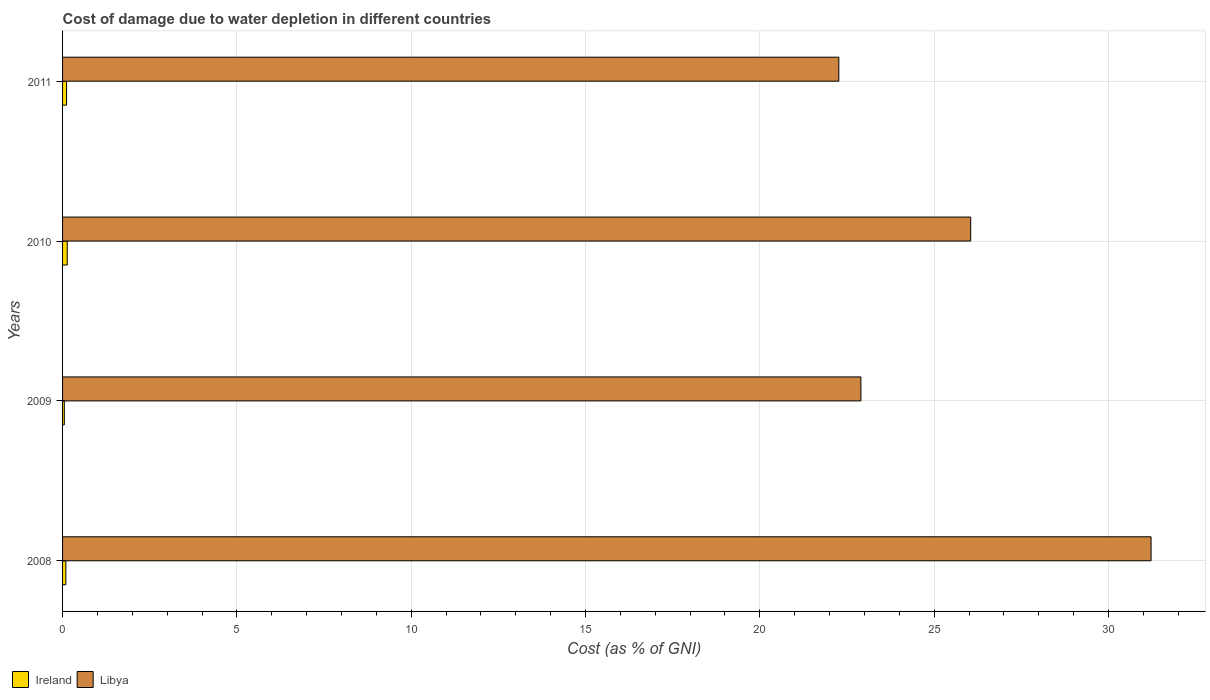How many different coloured bars are there?
Your response must be concise. 2. Are the number of bars per tick equal to the number of legend labels?
Your answer should be very brief. Yes. How many bars are there on the 3rd tick from the top?
Make the answer very short. 2. What is the label of the 3rd group of bars from the top?
Provide a short and direct response. 2009. What is the cost of damage caused due to water depletion in Libya in 2011?
Offer a very short reply. 22.26. Across all years, what is the maximum cost of damage caused due to water depletion in Ireland?
Your answer should be very brief. 0.13. Across all years, what is the minimum cost of damage caused due to water depletion in Libya?
Your response must be concise. 22.26. In which year was the cost of damage caused due to water depletion in Libya maximum?
Make the answer very short. 2008. What is the total cost of damage caused due to water depletion in Libya in the graph?
Offer a terse response. 102.43. What is the difference between the cost of damage caused due to water depletion in Ireland in 2008 and that in 2009?
Ensure brevity in your answer.  0.04. What is the difference between the cost of damage caused due to water depletion in Ireland in 2010 and the cost of damage caused due to water depletion in Libya in 2008?
Make the answer very short. -31.09. What is the average cost of damage caused due to water depletion in Ireland per year?
Your response must be concise. 0.1. In the year 2008, what is the difference between the cost of damage caused due to water depletion in Ireland and cost of damage caused due to water depletion in Libya?
Offer a terse response. -31.13. What is the ratio of the cost of damage caused due to water depletion in Ireland in 2008 to that in 2009?
Provide a short and direct response. 1.87. Is the cost of damage caused due to water depletion in Libya in 2009 less than that in 2010?
Offer a very short reply. Yes. What is the difference between the highest and the second highest cost of damage caused due to water depletion in Libya?
Provide a short and direct response. 5.17. What is the difference between the highest and the lowest cost of damage caused due to water depletion in Ireland?
Ensure brevity in your answer.  0.08. What does the 2nd bar from the top in 2010 represents?
Your answer should be compact. Ireland. What does the 1st bar from the bottom in 2008 represents?
Offer a very short reply. Ireland. Are the values on the major ticks of X-axis written in scientific E-notation?
Make the answer very short. No. Does the graph contain any zero values?
Provide a short and direct response. No. Does the graph contain grids?
Your answer should be compact. Yes. What is the title of the graph?
Provide a succinct answer. Cost of damage due to water depletion in different countries. What is the label or title of the X-axis?
Offer a very short reply. Cost (as % of GNI). What is the Cost (as % of GNI) of Ireland in 2008?
Your response must be concise. 0.09. What is the Cost (as % of GNI) in Libya in 2008?
Your answer should be very brief. 31.22. What is the Cost (as % of GNI) in Ireland in 2009?
Offer a very short reply. 0.05. What is the Cost (as % of GNI) of Libya in 2009?
Provide a short and direct response. 22.9. What is the Cost (as % of GNI) in Ireland in 2010?
Provide a succinct answer. 0.13. What is the Cost (as % of GNI) in Libya in 2010?
Your answer should be compact. 26.05. What is the Cost (as % of GNI) of Ireland in 2011?
Your answer should be very brief. 0.12. What is the Cost (as % of GNI) in Libya in 2011?
Offer a very short reply. 22.26. Across all years, what is the maximum Cost (as % of GNI) in Ireland?
Your answer should be very brief. 0.13. Across all years, what is the maximum Cost (as % of GNI) of Libya?
Give a very brief answer. 31.22. Across all years, what is the minimum Cost (as % of GNI) of Ireland?
Your answer should be compact. 0.05. Across all years, what is the minimum Cost (as % of GNI) of Libya?
Your response must be concise. 22.26. What is the total Cost (as % of GNI) of Ireland in the graph?
Ensure brevity in your answer.  0.39. What is the total Cost (as % of GNI) in Libya in the graph?
Your answer should be very brief. 102.43. What is the difference between the Cost (as % of GNI) in Ireland in 2008 and that in 2009?
Offer a terse response. 0.04. What is the difference between the Cost (as % of GNI) of Libya in 2008 and that in 2009?
Offer a very short reply. 8.32. What is the difference between the Cost (as % of GNI) of Ireland in 2008 and that in 2010?
Offer a terse response. -0.04. What is the difference between the Cost (as % of GNI) in Libya in 2008 and that in 2010?
Your answer should be very brief. 5.17. What is the difference between the Cost (as % of GNI) of Ireland in 2008 and that in 2011?
Make the answer very short. -0.02. What is the difference between the Cost (as % of GNI) in Libya in 2008 and that in 2011?
Offer a terse response. 8.96. What is the difference between the Cost (as % of GNI) in Ireland in 2009 and that in 2010?
Offer a terse response. -0.08. What is the difference between the Cost (as % of GNI) of Libya in 2009 and that in 2010?
Your answer should be compact. -3.15. What is the difference between the Cost (as % of GNI) in Ireland in 2009 and that in 2011?
Provide a short and direct response. -0.06. What is the difference between the Cost (as % of GNI) of Libya in 2009 and that in 2011?
Offer a very short reply. 0.63. What is the difference between the Cost (as % of GNI) of Ireland in 2010 and that in 2011?
Make the answer very short. 0.02. What is the difference between the Cost (as % of GNI) in Libya in 2010 and that in 2011?
Make the answer very short. 3.78. What is the difference between the Cost (as % of GNI) in Ireland in 2008 and the Cost (as % of GNI) in Libya in 2009?
Make the answer very short. -22.8. What is the difference between the Cost (as % of GNI) in Ireland in 2008 and the Cost (as % of GNI) in Libya in 2010?
Offer a very short reply. -25.95. What is the difference between the Cost (as % of GNI) of Ireland in 2008 and the Cost (as % of GNI) of Libya in 2011?
Ensure brevity in your answer.  -22.17. What is the difference between the Cost (as % of GNI) of Ireland in 2009 and the Cost (as % of GNI) of Libya in 2010?
Provide a succinct answer. -26. What is the difference between the Cost (as % of GNI) in Ireland in 2009 and the Cost (as % of GNI) in Libya in 2011?
Give a very brief answer. -22.21. What is the difference between the Cost (as % of GNI) of Ireland in 2010 and the Cost (as % of GNI) of Libya in 2011?
Your answer should be very brief. -22.13. What is the average Cost (as % of GNI) of Ireland per year?
Provide a succinct answer. 0.1. What is the average Cost (as % of GNI) in Libya per year?
Your answer should be very brief. 25.61. In the year 2008, what is the difference between the Cost (as % of GNI) of Ireland and Cost (as % of GNI) of Libya?
Keep it short and to the point. -31.13. In the year 2009, what is the difference between the Cost (as % of GNI) of Ireland and Cost (as % of GNI) of Libya?
Offer a terse response. -22.85. In the year 2010, what is the difference between the Cost (as % of GNI) of Ireland and Cost (as % of GNI) of Libya?
Make the answer very short. -25.91. In the year 2011, what is the difference between the Cost (as % of GNI) in Ireland and Cost (as % of GNI) in Libya?
Your answer should be very brief. -22.15. What is the ratio of the Cost (as % of GNI) of Ireland in 2008 to that in 2009?
Your answer should be very brief. 1.87. What is the ratio of the Cost (as % of GNI) in Libya in 2008 to that in 2009?
Offer a terse response. 1.36. What is the ratio of the Cost (as % of GNI) of Ireland in 2008 to that in 2010?
Give a very brief answer. 0.7. What is the ratio of the Cost (as % of GNI) of Libya in 2008 to that in 2010?
Your answer should be very brief. 1.2. What is the ratio of the Cost (as % of GNI) of Ireland in 2008 to that in 2011?
Offer a very short reply. 0.82. What is the ratio of the Cost (as % of GNI) of Libya in 2008 to that in 2011?
Give a very brief answer. 1.4. What is the ratio of the Cost (as % of GNI) of Ireland in 2009 to that in 2010?
Give a very brief answer. 0.38. What is the ratio of the Cost (as % of GNI) in Libya in 2009 to that in 2010?
Your response must be concise. 0.88. What is the ratio of the Cost (as % of GNI) of Ireland in 2009 to that in 2011?
Provide a succinct answer. 0.44. What is the ratio of the Cost (as % of GNI) of Libya in 2009 to that in 2011?
Offer a very short reply. 1.03. What is the ratio of the Cost (as % of GNI) of Ireland in 2010 to that in 2011?
Make the answer very short. 1.16. What is the ratio of the Cost (as % of GNI) of Libya in 2010 to that in 2011?
Provide a short and direct response. 1.17. What is the difference between the highest and the second highest Cost (as % of GNI) in Ireland?
Your answer should be compact. 0.02. What is the difference between the highest and the second highest Cost (as % of GNI) of Libya?
Your answer should be very brief. 5.17. What is the difference between the highest and the lowest Cost (as % of GNI) in Ireland?
Ensure brevity in your answer.  0.08. What is the difference between the highest and the lowest Cost (as % of GNI) of Libya?
Provide a succinct answer. 8.96. 